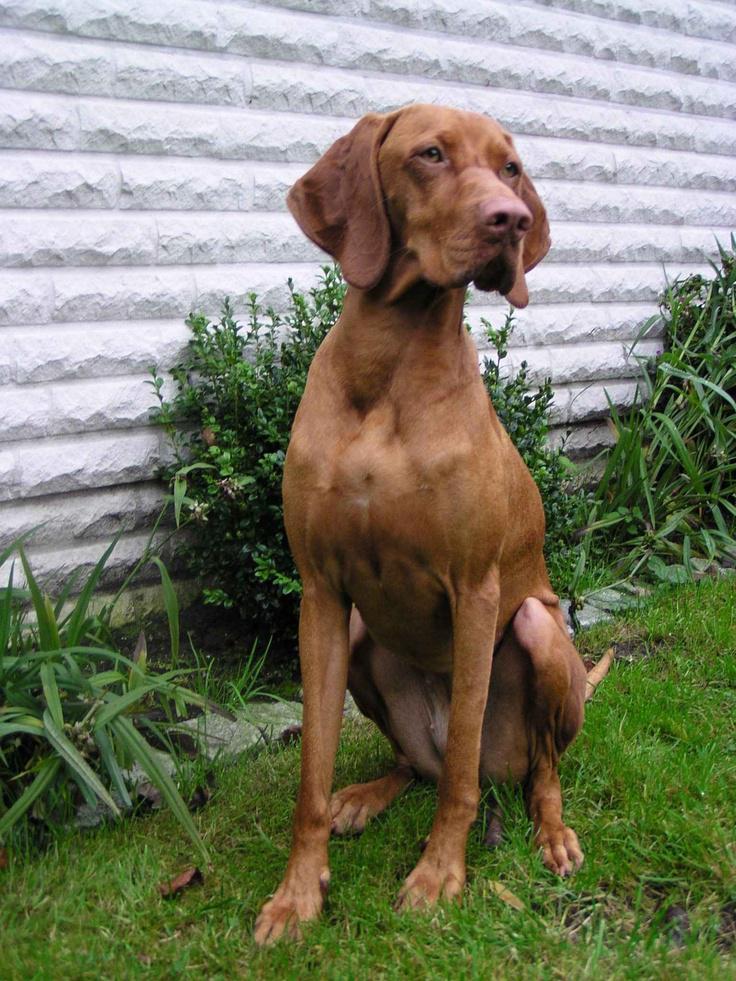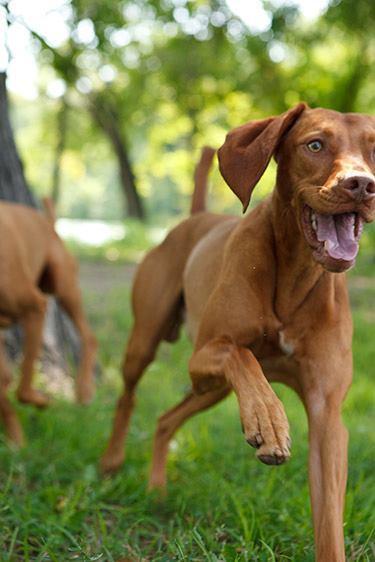The first image is the image on the left, the second image is the image on the right. Analyze the images presented: Is the assertion "There are only two dogs." valid? Answer yes or no. No. The first image is the image on the left, the second image is the image on the right. Assess this claim about the two images: "One image shows a dog running toward the camera, and the other image shows a dog in a still position gazing rightward.". Correct or not? Answer yes or no. Yes. 